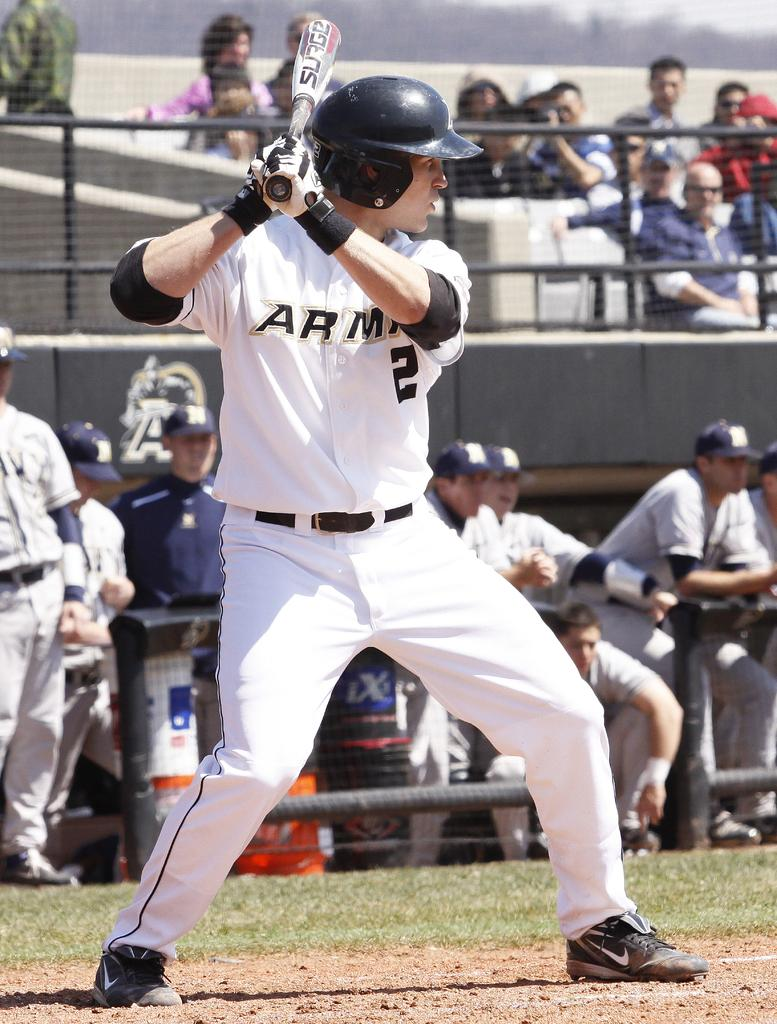<image>
Write a terse but informative summary of the picture. A professional baseball player holds his bat and intently waits for the pitch. 